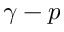Convert formula to latex. <formula><loc_0><loc_0><loc_500><loc_500>\gamma - p</formula> 